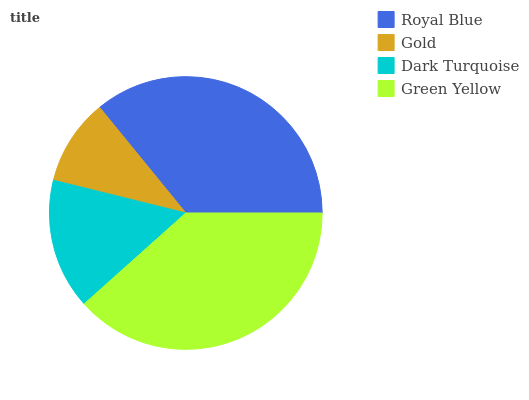Is Gold the minimum?
Answer yes or no. Yes. Is Green Yellow the maximum?
Answer yes or no. Yes. Is Dark Turquoise the minimum?
Answer yes or no. No. Is Dark Turquoise the maximum?
Answer yes or no. No. Is Dark Turquoise greater than Gold?
Answer yes or no. Yes. Is Gold less than Dark Turquoise?
Answer yes or no. Yes. Is Gold greater than Dark Turquoise?
Answer yes or no. No. Is Dark Turquoise less than Gold?
Answer yes or no. No. Is Royal Blue the high median?
Answer yes or no. Yes. Is Dark Turquoise the low median?
Answer yes or no. Yes. Is Dark Turquoise the high median?
Answer yes or no. No. Is Gold the low median?
Answer yes or no. No. 